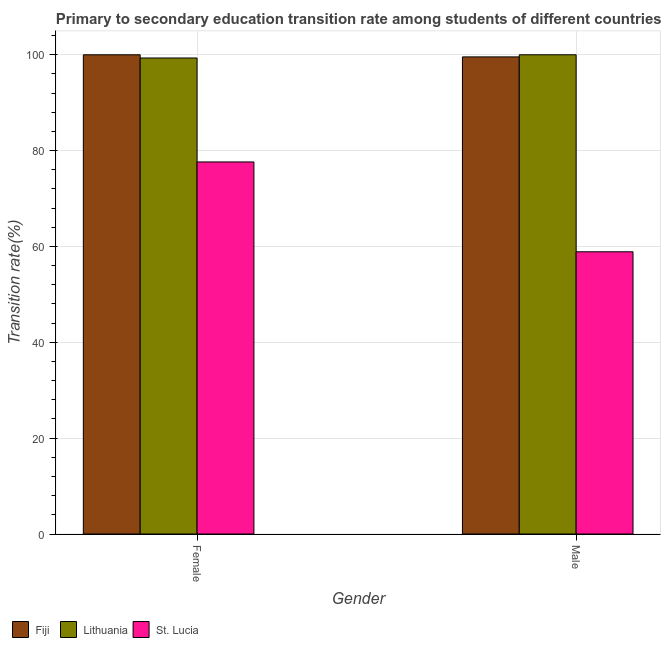How many different coloured bars are there?
Your answer should be very brief. 3. How many groups of bars are there?
Offer a terse response. 2. Are the number of bars per tick equal to the number of legend labels?
Provide a short and direct response. Yes. How many bars are there on the 2nd tick from the left?
Your response must be concise. 3. What is the transition rate among male students in St. Lucia?
Your answer should be very brief. 58.89. Across all countries, what is the maximum transition rate among male students?
Your response must be concise. 100. Across all countries, what is the minimum transition rate among female students?
Provide a succinct answer. 77.64. In which country was the transition rate among female students maximum?
Your response must be concise. Fiji. In which country was the transition rate among male students minimum?
Provide a succinct answer. St. Lucia. What is the total transition rate among male students in the graph?
Keep it short and to the point. 258.45. What is the difference between the transition rate among male students in Lithuania and that in St. Lucia?
Give a very brief answer. 41.11. What is the difference between the transition rate among female students in Fiji and the transition rate among male students in Lithuania?
Offer a very short reply. 0. What is the average transition rate among male students per country?
Your response must be concise. 86.15. What is the difference between the transition rate among male students and transition rate among female students in St. Lucia?
Offer a terse response. -18.75. What is the ratio of the transition rate among female students in Fiji to that in Lithuania?
Make the answer very short. 1.01. Is the transition rate among male students in Lithuania less than that in Fiji?
Provide a short and direct response. No. In how many countries, is the transition rate among female students greater than the average transition rate among female students taken over all countries?
Your answer should be very brief. 2. What does the 3rd bar from the left in Male represents?
Ensure brevity in your answer.  St. Lucia. What does the 1st bar from the right in Female represents?
Keep it short and to the point. St. Lucia. How many countries are there in the graph?
Ensure brevity in your answer.  3. What is the difference between two consecutive major ticks on the Y-axis?
Ensure brevity in your answer.  20. Are the values on the major ticks of Y-axis written in scientific E-notation?
Give a very brief answer. No. Where does the legend appear in the graph?
Offer a terse response. Bottom left. What is the title of the graph?
Your response must be concise. Primary to secondary education transition rate among students of different countries. Does "China" appear as one of the legend labels in the graph?
Provide a succinct answer. No. What is the label or title of the Y-axis?
Make the answer very short. Transition rate(%). What is the Transition rate(%) in Fiji in Female?
Provide a short and direct response. 100. What is the Transition rate(%) of Lithuania in Female?
Ensure brevity in your answer.  99.33. What is the Transition rate(%) in St. Lucia in Female?
Make the answer very short. 77.64. What is the Transition rate(%) of Fiji in Male?
Keep it short and to the point. 99.56. What is the Transition rate(%) in St. Lucia in Male?
Provide a short and direct response. 58.89. Across all Gender, what is the maximum Transition rate(%) in Lithuania?
Offer a terse response. 100. Across all Gender, what is the maximum Transition rate(%) of St. Lucia?
Give a very brief answer. 77.64. Across all Gender, what is the minimum Transition rate(%) of Fiji?
Ensure brevity in your answer.  99.56. Across all Gender, what is the minimum Transition rate(%) in Lithuania?
Ensure brevity in your answer.  99.33. Across all Gender, what is the minimum Transition rate(%) in St. Lucia?
Your answer should be very brief. 58.89. What is the total Transition rate(%) of Fiji in the graph?
Keep it short and to the point. 199.56. What is the total Transition rate(%) of Lithuania in the graph?
Ensure brevity in your answer.  199.33. What is the total Transition rate(%) in St. Lucia in the graph?
Ensure brevity in your answer.  136.53. What is the difference between the Transition rate(%) of Fiji in Female and that in Male?
Provide a short and direct response. 0.44. What is the difference between the Transition rate(%) of Lithuania in Female and that in Male?
Offer a terse response. -0.67. What is the difference between the Transition rate(%) in St. Lucia in Female and that in Male?
Your response must be concise. 18.75. What is the difference between the Transition rate(%) of Fiji in Female and the Transition rate(%) of Lithuania in Male?
Your answer should be compact. 0. What is the difference between the Transition rate(%) of Fiji in Female and the Transition rate(%) of St. Lucia in Male?
Your answer should be very brief. 41.11. What is the difference between the Transition rate(%) of Lithuania in Female and the Transition rate(%) of St. Lucia in Male?
Give a very brief answer. 40.44. What is the average Transition rate(%) of Fiji per Gender?
Provide a succinct answer. 99.78. What is the average Transition rate(%) in Lithuania per Gender?
Keep it short and to the point. 99.67. What is the average Transition rate(%) in St. Lucia per Gender?
Keep it short and to the point. 68.26. What is the difference between the Transition rate(%) of Fiji and Transition rate(%) of Lithuania in Female?
Your answer should be compact. 0.67. What is the difference between the Transition rate(%) in Fiji and Transition rate(%) in St. Lucia in Female?
Provide a short and direct response. 22.36. What is the difference between the Transition rate(%) of Lithuania and Transition rate(%) of St. Lucia in Female?
Ensure brevity in your answer.  21.69. What is the difference between the Transition rate(%) of Fiji and Transition rate(%) of Lithuania in Male?
Provide a succinct answer. -0.44. What is the difference between the Transition rate(%) of Fiji and Transition rate(%) of St. Lucia in Male?
Offer a very short reply. 40.67. What is the difference between the Transition rate(%) of Lithuania and Transition rate(%) of St. Lucia in Male?
Keep it short and to the point. 41.11. What is the ratio of the Transition rate(%) in Fiji in Female to that in Male?
Your response must be concise. 1. What is the ratio of the Transition rate(%) of Lithuania in Female to that in Male?
Ensure brevity in your answer.  0.99. What is the ratio of the Transition rate(%) of St. Lucia in Female to that in Male?
Your answer should be compact. 1.32. What is the difference between the highest and the second highest Transition rate(%) in Fiji?
Give a very brief answer. 0.44. What is the difference between the highest and the second highest Transition rate(%) of Lithuania?
Provide a short and direct response. 0.67. What is the difference between the highest and the second highest Transition rate(%) in St. Lucia?
Your response must be concise. 18.75. What is the difference between the highest and the lowest Transition rate(%) in Fiji?
Provide a short and direct response. 0.44. What is the difference between the highest and the lowest Transition rate(%) in Lithuania?
Your response must be concise. 0.67. What is the difference between the highest and the lowest Transition rate(%) in St. Lucia?
Your response must be concise. 18.75. 